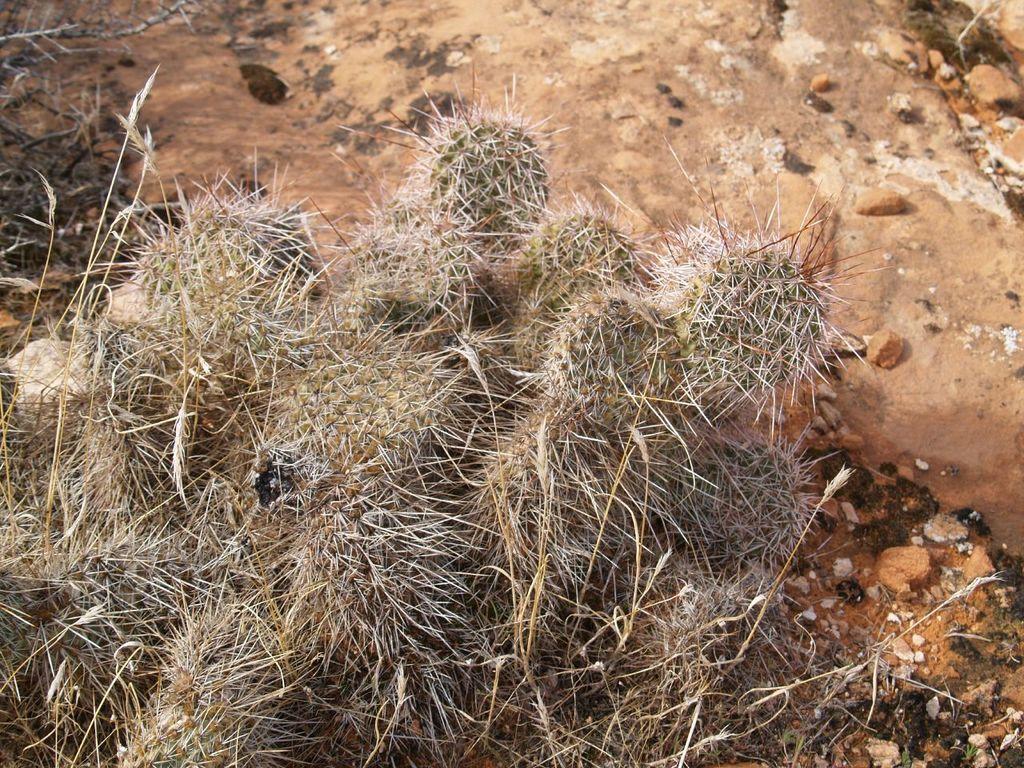In one or two sentences, can you explain what this image depicts? In the picture I can see plants, stones and some other things. 